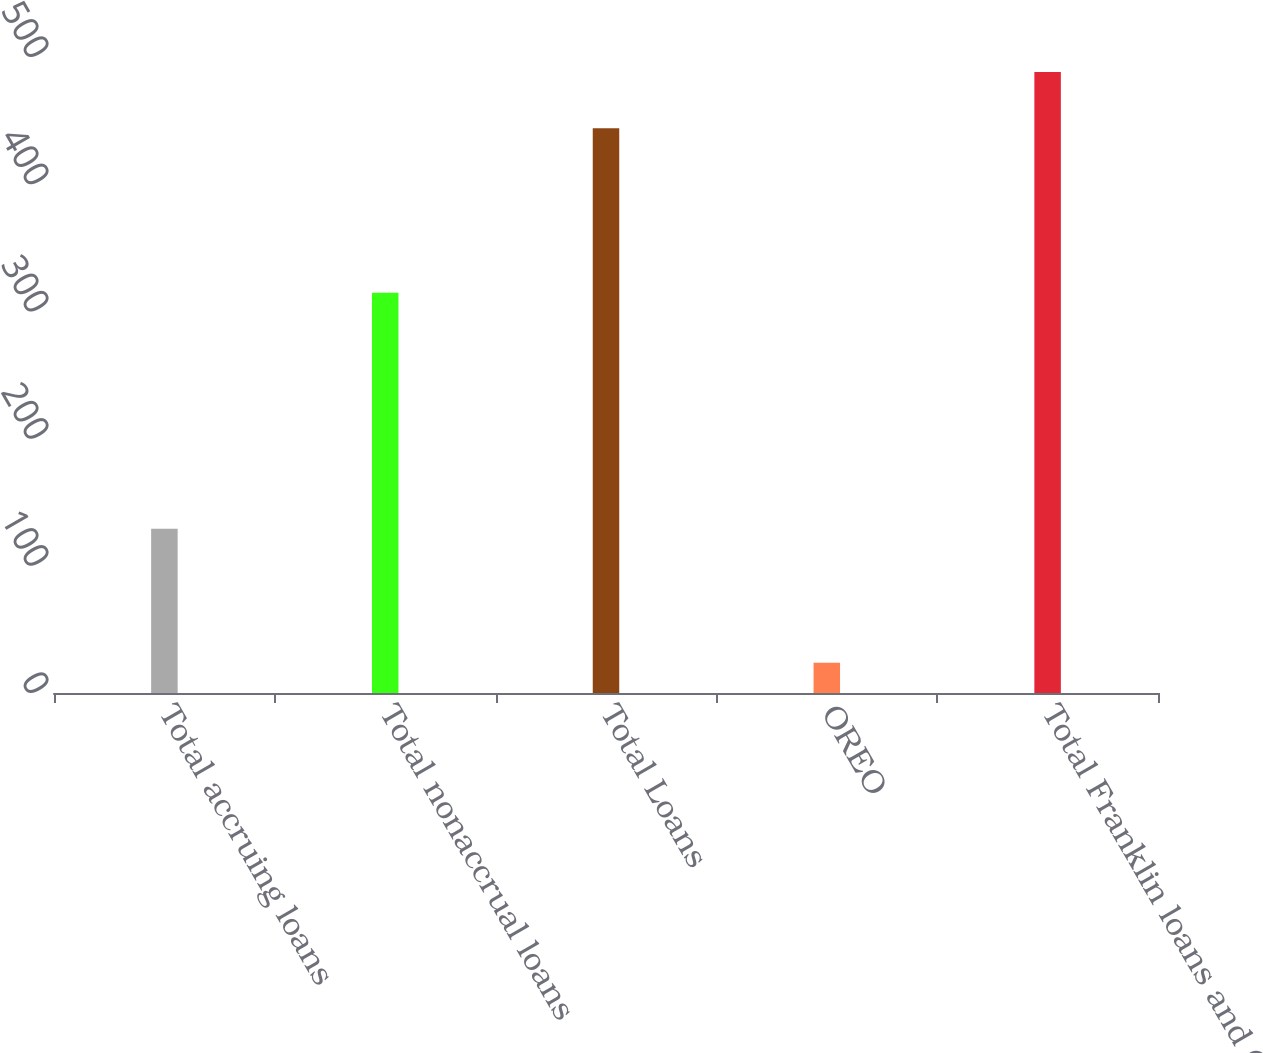<chart> <loc_0><loc_0><loc_500><loc_500><bar_chart><fcel>Total accruing loans<fcel>Total nonaccrual loans<fcel>Total Loans<fcel>OREO<fcel>Total Franklin loans and OREO<nl><fcel>129.2<fcel>314.7<fcel>443.9<fcel>23.8<fcel>488.29<nl></chart> 